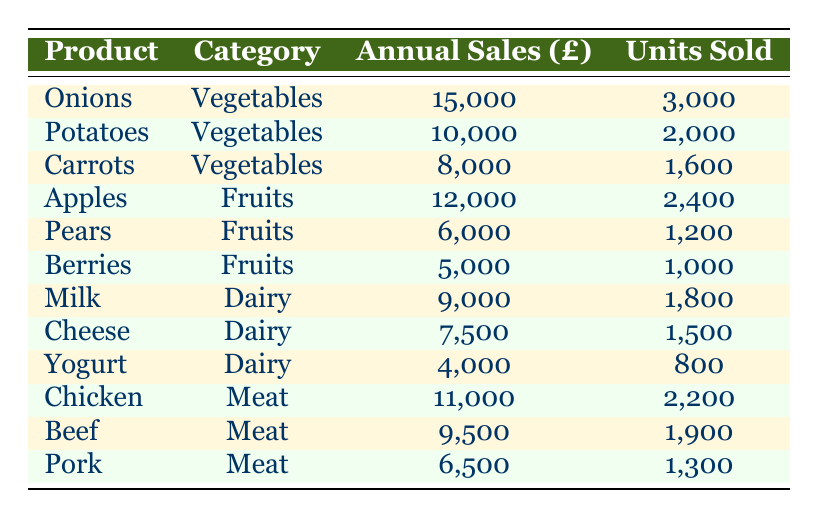What are the annual sales for Onions? The table lists Onions under the Vegetables category, with the corresponding annual sales amount shown as 15,000.
Answer: 15,000 How many units of Chicken were sold? From the table, Chicken is categorized under Meat, and the number of units sold is directly listed as 2,200.
Answer: 2,200 Which product category has the highest annual sales? By comparing the annual sales for all categories, Vegetables (with 15,000 from Onions) has the highest total, when considering all items, it sums to 33,000.
Answer: Vegetables What is the total annual sales for Dairy products? The annual sales for Milk, Cheese, and Yogurt are 9,000, 7,500, and 4,000 respectively. Adding these amounts gives 9,000 + 7,500 + 4,000 = 20,500.
Answer: 20,500 Is the annual sales for Beef greater than that for Milk? The annual sales for Beef are 9,500 and for Milk, it is 9,000. Since 9,500 is greater than 9,000, the answer is yes.
Answer: Yes What is the average units sold for all fruit products? The units sold for Apples, Pears, and Berries are 2,400, 1,200, and 1,000 respectively. Adding these gives a total of 4,600. Dividing this by 3 (the number of products) gives an average: 4,600 / 3 = 1,533.33.
Answer: 1,533.33 How many more units of Potatoes were sold than Pork? Potatoes have 2,000 units sold, while Pork has 1,300. Subtracting these gives 2,000 - 1,300 = 700.
Answer: 700 What is the total annual sales for vegetables compared to fruits? The annual sales for Vegetables is 33,000 (15,000 + 10,000 + 8,000), and for Fruits, it is 23,000 (12,000 + 6,000 + 5,000). Since 33,000 is more than 23,000, Vegetables exceeds Fruits.
Answer: Vegetables exceed Fruits Which Dairy item has the highest sales? A comparison of the annual sales shows Milk at 9,000, Cheese at 7,500, and Yogurt at 4,000. Since 9,000 is the greatest, Milk has the highest sales.
Answer: Milk 